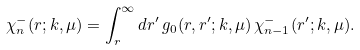Convert formula to latex. <formula><loc_0><loc_0><loc_500><loc_500>\chi ^ { - } _ { n } ( r ; k , \mu ) = \int ^ { \infty } _ { r } d r ^ { \prime } \, g _ { 0 } ( r , r ^ { \prime } ; k , \mu ) \, \chi ^ { - } _ { n - 1 } ( r ^ { \prime } ; k , \mu ) .</formula> 